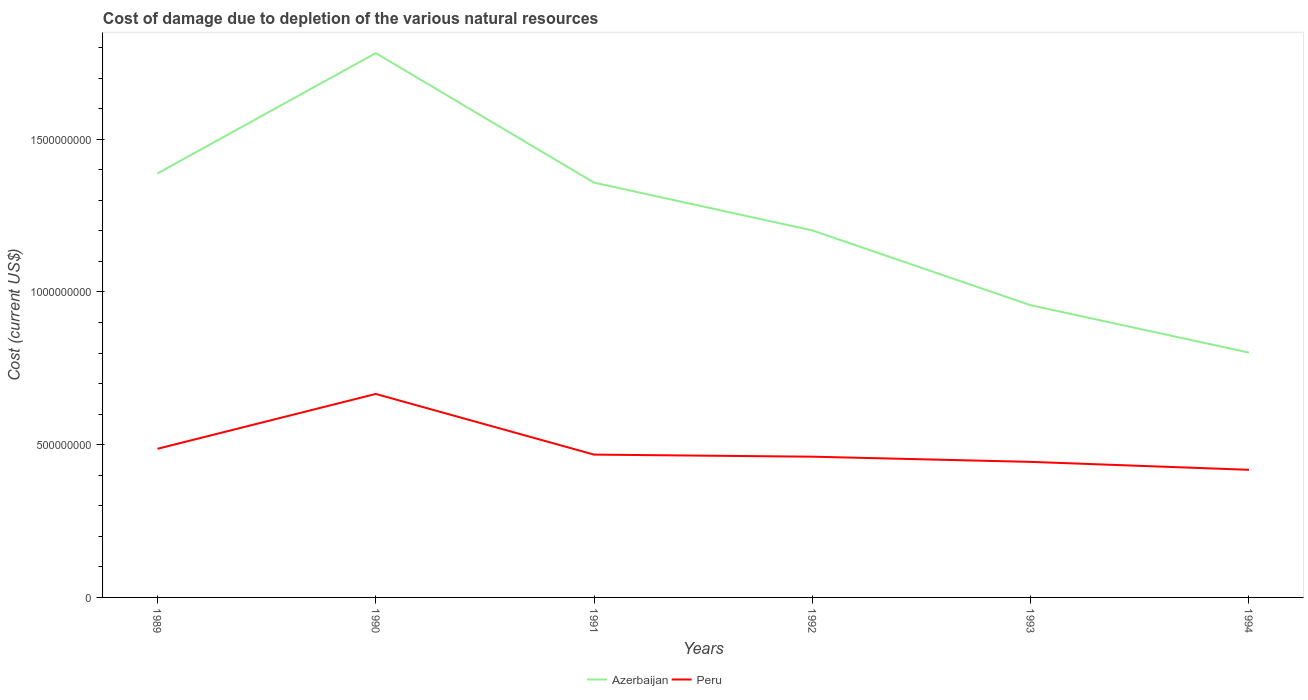How many different coloured lines are there?
Your response must be concise. 2. Across all years, what is the maximum cost of damage caused due to the depletion of various natural resources in Azerbaijan?
Ensure brevity in your answer.  8.01e+08. In which year was the cost of damage caused due to the depletion of various natural resources in Azerbaijan maximum?
Provide a short and direct response. 1994. What is the total cost of damage caused due to the depletion of various natural resources in Peru in the graph?
Your answer should be compact. 1.91e+07. What is the difference between the highest and the second highest cost of damage caused due to the depletion of various natural resources in Peru?
Offer a very short reply. 2.48e+08. What is the difference between the highest and the lowest cost of damage caused due to the depletion of various natural resources in Azerbaijan?
Provide a short and direct response. 3. Is the cost of damage caused due to the depletion of various natural resources in Peru strictly greater than the cost of damage caused due to the depletion of various natural resources in Azerbaijan over the years?
Your response must be concise. Yes. What is the difference between two consecutive major ticks on the Y-axis?
Your answer should be very brief. 5.00e+08. Does the graph contain any zero values?
Your answer should be very brief. No. What is the title of the graph?
Offer a terse response. Cost of damage due to depletion of the various natural resources. What is the label or title of the Y-axis?
Provide a short and direct response. Cost (current US$). What is the Cost (current US$) in Azerbaijan in 1989?
Give a very brief answer. 1.39e+09. What is the Cost (current US$) of Peru in 1989?
Make the answer very short. 4.87e+08. What is the Cost (current US$) in Azerbaijan in 1990?
Offer a terse response. 1.78e+09. What is the Cost (current US$) of Peru in 1990?
Provide a succinct answer. 6.66e+08. What is the Cost (current US$) in Azerbaijan in 1991?
Keep it short and to the point. 1.36e+09. What is the Cost (current US$) of Peru in 1991?
Your answer should be compact. 4.67e+08. What is the Cost (current US$) of Azerbaijan in 1992?
Your response must be concise. 1.20e+09. What is the Cost (current US$) in Peru in 1992?
Offer a terse response. 4.61e+08. What is the Cost (current US$) of Azerbaijan in 1993?
Ensure brevity in your answer.  9.57e+08. What is the Cost (current US$) in Peru in 1993?
Give a very brief answer. 4.44e+08. What is the Cost (current US$) in Azerbaijan in 1994?
Your answer should be very brief. 8.01e+08. What is the Cost (current US$) in Peru in 1994?
Ensure brevity in your answer.  4.18e+08. Across all years, what is the maximum Cost (current US$) in Azerbaijan?
Offer a very short reply. 1.78e+09. Across all years, what is the maximum Cost (current US$) in Peru?
Your response must be concise. 6.66e+08. Across all years, what is the minimum Cost (current US$) in Azerbaijan?
Provide a succinct answer. 8.01e+08. Across all years, what is the minimum Cost (current US$) in Peru?
Offer a very short reply. 4.18e+08. What is the total Cost (current US$) of Azerbaijan in the graph?
Give a very brief answer. 7.49e+09. What is the total Cost (current US$) in Peru in the graph?
Make the answer very short. 2.94e+09. What is the difference between the Cost (current US$) in Azerbaijan in 1989 and that in 1990?
Keep it short and to the point. -3.94e+08. What is the difference between the Cost (current US$) in Peru in 1989 and that in 1990?
Offer a terse response. -1.80e+08. What is the difference between the Cost (current US$) in Azerbaijan in 1989 and that in 1991?
Ensure brevity in your answer.  3.01e+07. What is the difference between the Cost (current US$) of Peru in 1989 and that in 1991?
Provide a short and direct response. 1.91e+07. What is the difference between the Cost (current US$) of Azerbaijan in 1989 and that in 1992?
Ensure brevity in your answer.  1.86e+08. What is the difference between the Cost (current US$) of Peru in 1989 and that in 1992?
Your answer should be very brief. 2.59e+07. What is the difference between the Cost (current US$) in Azerbaijan in 1989 and that in 1993?
Provide a short and direct response. 4.31e+08. What is the difference between the Cost (current US$) in Peru in 1989 and that in 1993?
Your answer should be very brief. 4.28e+07. What is the difference between the Cost (current US$) of Azerbaijan in 1989 and that in 1994?
Give a very brief answer. 5.86e+08. What is the difference between the Cost (current US$) in Peru in 1989 and that in 1994?
Offer a terse response. 6.88e+07. What is the difference between the Cost (current US$) in Azerbaijan in 1990 and that in 1991?
Give a very brief answer. 4.24e+08. What is the difference between the Cost (current US$) of Peru in 1990 and that in 1991?
Ensure brevity in your answer.  1.99e+08. What is the difference between the Cost (current US$) in Azerbaijan in 1990 and that in 1992?
Keep it short and to the point. 5.80e+08. What is the difference between the Cost (current US$) of Peru in 1990 and that in 1992?
Keep it short and to the point. 2.05e+08. What is the difference between the Cost (current US$) of Azerbaijan in 1990 and that in 1993?
Offer a terse response. 8.25e+08. What is the difference between the Cost (current US$) of Peru in 1990 and that in 1993?
Offer a terse response. 2.22e+08. What is the difference between the Cost (current US$) of Azerbaijan in 1990 and that in 1994?
Your response must be concise. 9.80e+08. What is the difference between the Cost (current US$) of Peru in 1990 and that in 1994?
Offer a very short reply. 2.48e+08. What is the difference between the Cost (current US$) of Azerbaijan in 1991 and that in 1992?
Provide a short and direct response. 1.56e+08. What is the difference between the Cost (current US$) of Peru in 1991 and that in 1992?
Give a very brief answer. 6.82e+06. What is the difference between the Cost (current US$) of Azerbaijan in 1991 and that in 1993?
Make the answer very short. 4.01e+08. What is the difference between the Cost (current US$) in Peru in 1991 and that in 1993?
Your response must be concise. 2.38e+07. What is the difference between the Cost (current US$) of Azerbaijan in 1991 and that in 1994?
Offer a terse response. 5.56e+08. What is the difference between the Cost (current US$) in Peru in 1991 and that in 1994?
Offer a terse response. 4.98e+07. What is the difference between the Cost (current US$) in Azerbaijan in 1992 and that in 1993?
Provide a short and direct response. 2.45e+08. What is the difference between the Cost (current US$) of Peru in 1992 and that in 1993?
Ensure brevity in your answer.  1.70e+07. What is the difference between the Cost (current US$) of Azerbaijan in 1992 and that in 1994?
Keep it short and to the point. 4.00e+08. What is the difference between the Cost (current US$) in Peru in 1992 and that in 1994?
Make the answer very short. 4.30e+07. What is the difference between the Cost (current US$) in Azerbaijan in 1993 and that in 1994?
Offer a terse response. 1.55e+08. What is the difference between the Cost (current US$) of Peru in 1993 and that in 1994?
Offer a terse response. 2.60e+07. What is the difference between the Cost (current US$) in Azerbaijan in 1989 and the Cost (current US$) in Peru in 1990?
Give a very brief answer. 7.22e+08. What is the difference between the Cost (current US$) in Azerbaijan in 1989 and the Cost (current US$) in Peru in 1991?
Offer a terse response. 9.20e+08. What is the difference between the Cost (current US$) of Azerbaijan in 1989 and the Cost (current US$) of Peru in 1992?
Your answer should be compact. 9.27e+08. What is the difference between the Cost (current US$) of Azerbaijan in 1989 and the Cost (current US$) of Peru in 1993?
Keep it short and to the point. 9.44e+08. What is the difference between the Cost (current US$) of Azerbaijan in 1989 and the Cost (current US$) of Peru in 1994?
Provide a succinct answer. 9.70e+08. What is the difference between the Cost (current US$) in Azerbaijan in 1990 and the Cost (current US$) in Peru in 1991?
Make the answer very short. 1.31e+09. What is the difference between the Cost (current US$) in Azerbaijan in 1990 and the Cost (current US$) in Peru in 1992?
Provide a short and direct response. 1.32e+09. What is the difference between the Cost (current US$) of Azerbaijan in 1990 and the Cost (current US$) of Peru in 1993?
Ensure brevity in your answer.  1.34e+09. What is the difference between the Cost (current US$) of Azerbaijan in 1990 and the Cost (current US$) of Peru in 1994?
Provide a short and direct response. 1.36e+09. What is the difference between the Cost (current US$) in Azerbaijan in 1991 and the Cost (current US$) in Peru in 1992?
Keep it short and to the point. 8.97e+08. What is the difference between the Cost (current US$) of Azerbaijan in 1991 and the Cost (current US$) of Peru in 1993?
Your response must be concise. 9.14e+08. What is the difference between the Cost (current US$) in Azerbaijan in 1991 and the Cost (current US$) in Peru in 1994?
Your answer should be compact. 9.40e+08. What is the difference between the Cost (current US$) of Azerbaijan in 1992 and the Cost (current US$) of Peru in 1993?
Provide a succinct answer. 7.58e+08. What is the difference between the Cost (current US$) in Azerbaijan in 1992 and the Cost (current US$) in Peru in 1994?
Give a very brief answer. 7.84e+08. What is the difference between the Cost (current US$) of Azerbaijan in 1993 and the Cost (current US$) of Peru in 1994?
Your response must be concise. 5.39e+08. What is the average Cost (current US$) in Azerbaijan per year?
Provide a short and direct response. 1.25e+09. What is the average Cost (current US$) of Peru per year?
Ensure brevity in your answer.  4.90e+08. In the year 1989, what is the difference between the Cost (current US$) of Azerbaijan and Cost (current US$) of Peru?
Your answer should be very brief. 9.01e+08. In the year 1990, what is the difference between the Cost (current US$) in Azerbaijan and Cost (current US$) in Peru?
Your response must be concise. 1.12e+09. In the year 1991, what is the difference between the Cost (current US$) in Azerbaijan and Cost (current US$) in Peru?
Your response must be concise. 8.90e+08. In the year 1992, what is the difference between the Cost (current US$) in Azerbaijan and Cost (current US$) in Peru?
Provide a short and direct response. 7.41e+08. In the year 1993, what is the difference between the Cost (current US$) in Azerbaijan and Cost (current US$) in Peru?
Your response must be concise. 5.13e+08. In the year 1994, what is the difference between the Cost (current US$) of Azerbaijan and Cost (current US$) of Peru?
Your response must be concise. 3.84e+08. What is the ratio of the Cost (current US$) in Azerbaijan in 1989 to that in 1990?
Provide a short and direct response. 0.78. What is the ratio of the Cost (current US$) of Peru in 1989 to that in 1990?
Provide a short and direct response. 0.73. What is the ratio of the Cost (current US$) of Azerbaijan in 1989 to that in 1991?
Ensure brevity in your answer.  1.02. What is the ratio of the Cost (current US$) of Peru in 1989 to that in 1991?
Provide a short and direct response. 1.04. What is the ratio of the Cost (current US$) of Azerbaijan in 1989 to that in 1992?
Keep it short and to the point. 1.16. What is the ratio of the Cost (current US$) of Peru in 1989 to that in 1992?
Make the answer very short. 1.06. What is the ratio of the Cost (current US$) of Azerbaijan in 1989 to that in 1993?
Offer a terse response. 1.45. What is the ratio of the Cost (current US$) in Peru in 1989 to that in 1993?
Make the answer very short. 1.1. What is the ratio of the Cost (current US$) in Azerbaijan in 1989 to that in 1994?
Make the answer very short. 1.73. What is the ratio of the Cost (current US$) of Peru in 1989 to that in 1994?
Offer a terse response. 1.16. What is the ratio of the Cost (current US$) of Azerbaijan in 1990 to that in 1991?
Your answer should be very brief. 1.31. What is the ratio of the Cost (current US$) in Peru in 1990 to that in 1991?
Provide a succinct answer. 1.42. What is the ratio of the Cost (current US$) of Azerbaijan in 1990 to that in 1992?
Offer a terse response. 1.48. What is the ratio of the Cost (current US$) in Peru in 1990 to that in 1992?
Your answer should be compact. 1.45. What is the ratio of the Cost (current US$) of Azerbaijan in 1990 to that in 1993?
Ensure brevity in your answer.  1.86. What is the ratio of the Cost (current US$) in Peru in 1990 to that in 1993?
Ensure brevity in your answer.  1.5. What is the ratio of the Cost (current US$) of Azerbaijan in 1990 to that in 1994?
Ensure brevity in your answer.  2.22. What is the ratio of the Cost (current US$) in Peru in 1990 to that in 1994?
Keep it short and to the point. 1.59. What is the ratio of the Cost (current US$) in Azerbaijan in 1991 to that in 1992?
Your answer should be very brief. 1.13. What is the ratio of the Cost (current US$) of Peru in 1991 to that in 1992?
Offer a terse response. 1.01. What is the ratio of the Cost (current US$) of Azerbaijan in 1991 to that in 1993?
Ensure brevity in your answer.  1.42. What is the ratio of the Cost (current US$) of Peru in 1991 to that in 1993?
Offer a very short reply. 1.05. What is the ratio of the Cost (current US$) of Azerbaijan in 1991 to that in 1994?
Give a very brief answer. 1.69. What is the ratio of the Cost (current US$) in Peru in 1991 to that in 1994?
Keep it short and to the point. 1.12. What is the ratio of the Cost (current US$) in Azerbaijan in 1992 to that in 1993?
Your answer should be very brief. 1.26. What is the ratio of the Cost (current US$) in Peru in 1992 to that in 1993?
Make the answer very short. 1.04. What is the ratio of the Cost (current US$) in Azerbaijan in 1992 to that in 1994?
Provide a succinct answer. 1.5. What is the ratio of the Cost (current US$) in Peru in 1992 to that in 1994?
Give a very brief answer. 1.1. What is the ratio of the Cost (current US$) in Azerbaijan in 1993 to that in 1994?
Provide a succinct answer. 1.19. What is the ratio of the Cost (current US$) of Peru in 1993 to that in 1994?
Provide a succinct answer. 1.06. What is the difference between the highest and the second highest Cost (current US$) of Azerbaijan?
Give a very brief answer. 3.94e+08. What is the difference between the highest and the second highest Cost (current US$) of Peru?
Offer a very short reply. 1.80e+08. What is the difference between the highest and the lowest Cost (current US$) in Azerbaijan?
Your response must be concise. 9.80e+08. What is the difference between the highest and the lowest Cost (current US$) in Peru?
Keep it short and to the point. 2.48e+08. 